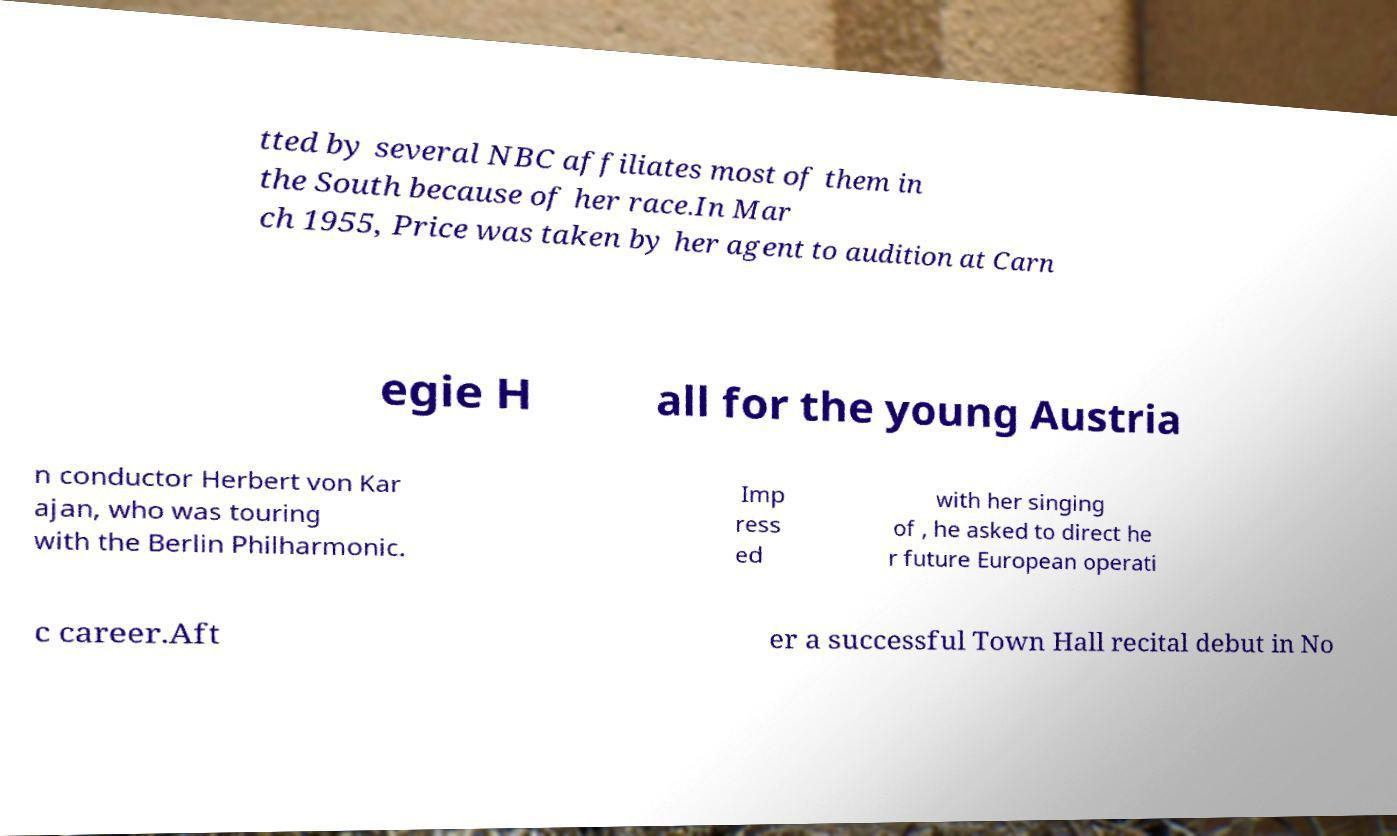Can you accurately transcribe the text from the provided image for me? tted by several NBC affiliates most of them in the South because of her race.In Mar ch 1955, Price was taken by her agent to audition at Carn egie H all for the young Austria n conductor Herbert von Kar ajan, who was touring with the Berlin Philharmonic. Imp ress ed with her singing of , he asked to direct he r future European operati c career.Aft er a successful Town Hall recital debut in No 